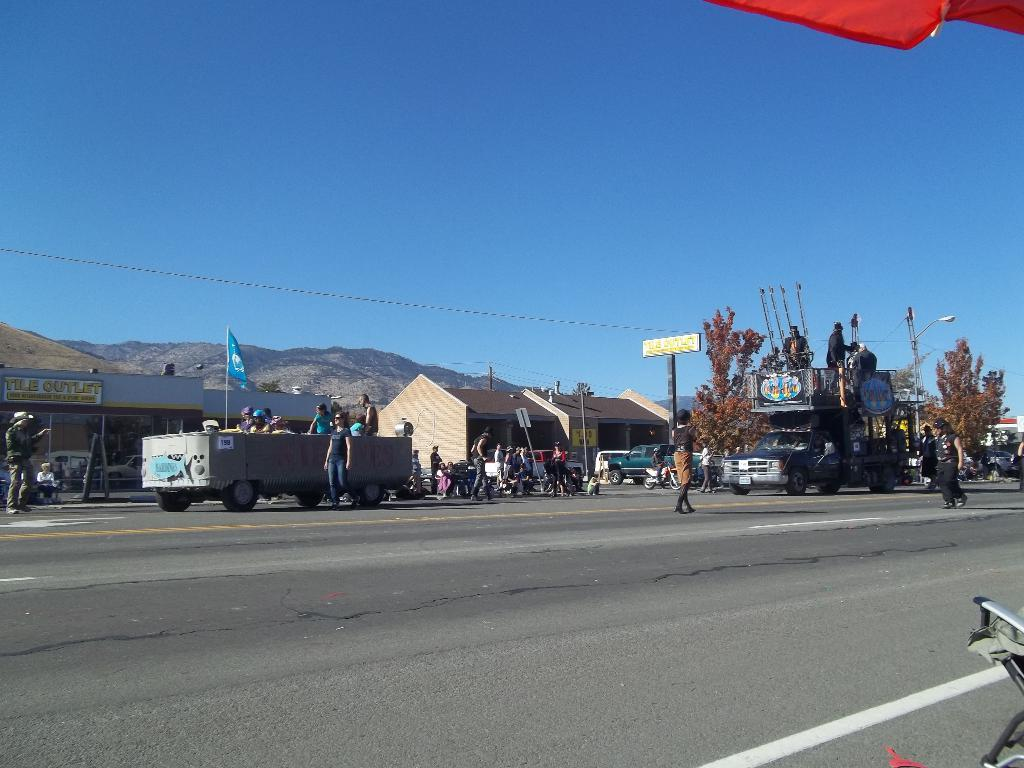How many people are in the image? There is a group of people in the image, but the exact number is not specified. What can be seen on the road in the image? There are vehicles on the road in the image. What is the flag associated with in the image? The flag is present in the image, but its specific purpose or association is not mentioned. What type of structures are visible in the image? There are buildings in the image. What natural features can be seen in the image? There are mountains and trees in the image. What are the poles used for in the image? The purpose of the poles in the image is not specified. What are the unspecified objects in the image? The nature or purpose of the unspecified objects in the image is not mentioned. What is visible in the background of the image? The sky is visible in the background of the image. How many snakes are slithering on the flag in the image? There are no snakes present in the image, and the flag does not have any snakes on it. What invention is being demonstrated by the group of people in the image? There is no invention being demonstrated by the group of people in the image. What color is the silver object in the image? There is no silver object present in the image. 